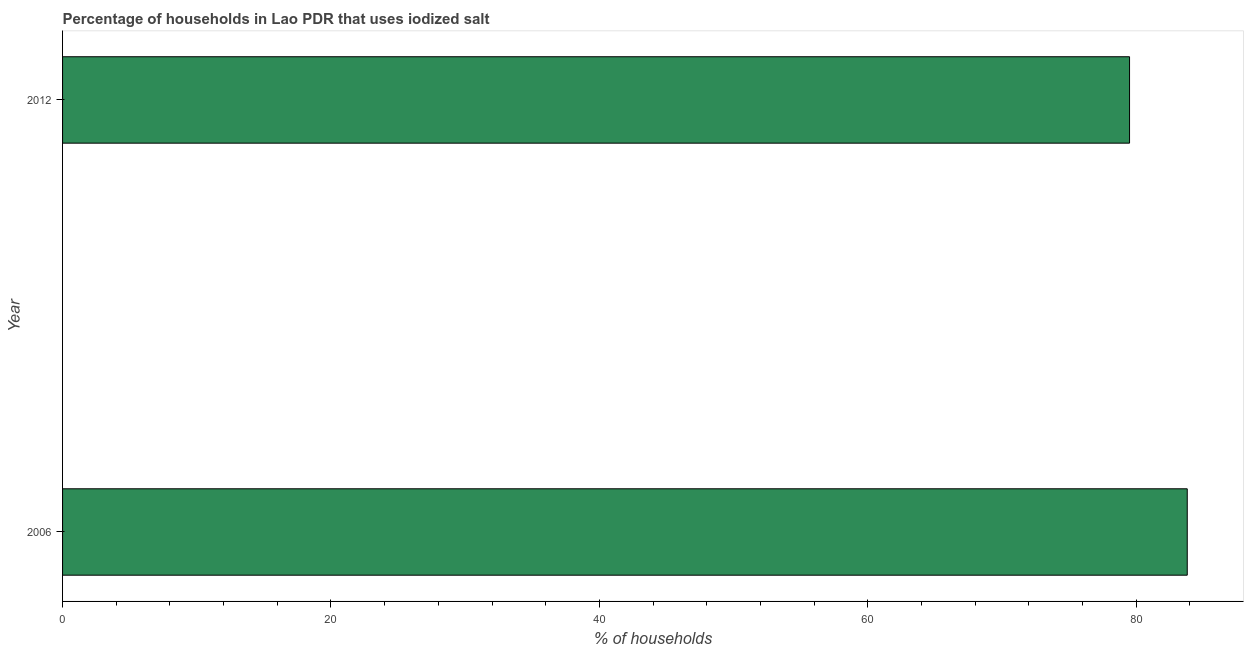Does the graph contain grids?
Your answer should be very brief. No. What is the title of the graph?
Provide a short and direct response. Percentage of households in Lao PDR that uses iodized salt. What is the label or title of the X-axis?
Your answer should be very brief. % of households. What is the label or title of the Y-axis?
Offer a very short reply. Year. What is the percentage of households where iodized salt is consumed in 2006?
Offer a terse response. 83.8. Across all years, what is the maximum percentage of households where iodized salt is consumed?
Offer a very short reply. 83.8. Across all years, what is the minimum percentage of households where iodized salt is consumed?
Give a very brief answer. 79.5. What is the sum of the percentage of households where iodized salt is consumed?
Ensure brevity in your answer.  163.3. What is the average percentage of households where iodized salt is consumed per year?
Offer a terse response. 81.65. What is the median percentage of households where iodized salt is consumed?
Offer a terse response. 81.65. What is the ratio of the percentage of households where iodized salt is consumed in 2006 to that in 2012?
Provide a short and direct response. 1.05. Is the percentage of households where iodized salt is consumed in 2006 less than that in 2012?
Your answer should be compact. No. How many bars are there?
Keep it short and to the point. 2. How many years are there in the graph?
Ensure brevity in your answer.  2. What is the % of households in 2006?
Provide a succinct answer. 83.8. What is the % of households of 2012?
Offer a terse response. 79.5. What is the ratio of the % of households in 2006 to that in 2012?
Keep it short and to the point. 1.05. 